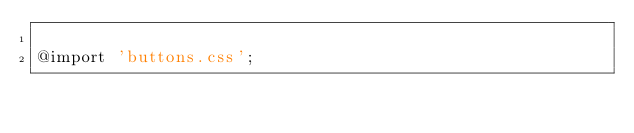Convert code to text. <code><loc_0><loc_0><loc_500><loc_500><_CSS_>
@import 'buttons.css';
</code> 